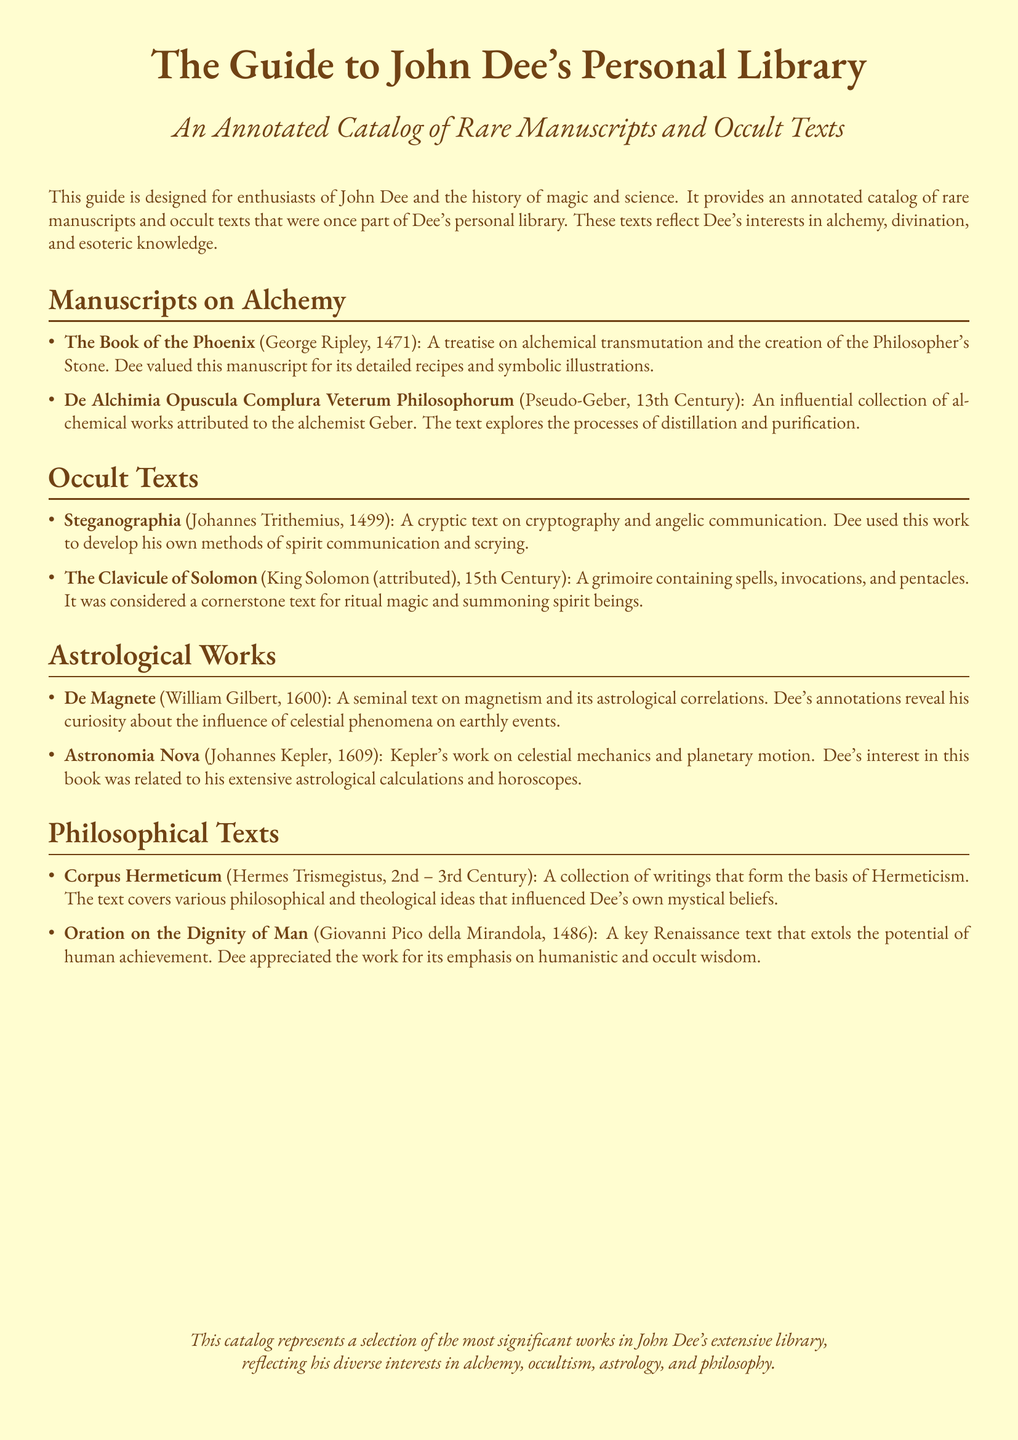What is the title of the guide? The title of the guide is presented at the top of the document and establishes its focus.
Answer: The Guide to John Dee's Personal Library Who authored "The Book of the Phoenix"? The document lists George Ripley as the author of this alchemical treatise.
Answer: George Ripley In what year was "De Magnete" published? The document specifies the publication year of "De Magnete."
Answer: 1600 What collection is attributed to Hermes Trismegistus? The document indicates the "Corpus Hermeticum" as a significant collection by Hermes Trismegistus.
Answer: Corpus Hermeticum Which text focuses on cryptography and angelic communication? The guide details "Steganographia" as a key work in this category.
Answer: Steganographia What is a major theme in "Oration on the Dignity of Man"? The document highlights the potential of human achievement as a central theme in this philosophical text.
Answer: Human achievement Which author corresponds to "Astronomia Nova"? The author of "Astronomia Nova" is provided in the document.
Answer: Johannes Kepler Why did Dee value "The Book of the Phoenix"? The document notes that Dee appreciated this manuscript for its detailed recipes and symbolic illustrations.
Answer: Detailed recipes and symbolic illustrations What era does the "De Alchimia Opuscula Complura Veterum Philosophorum" belong to? The document describes this collection as being from the 13th Century.
Answer: 13th Century 